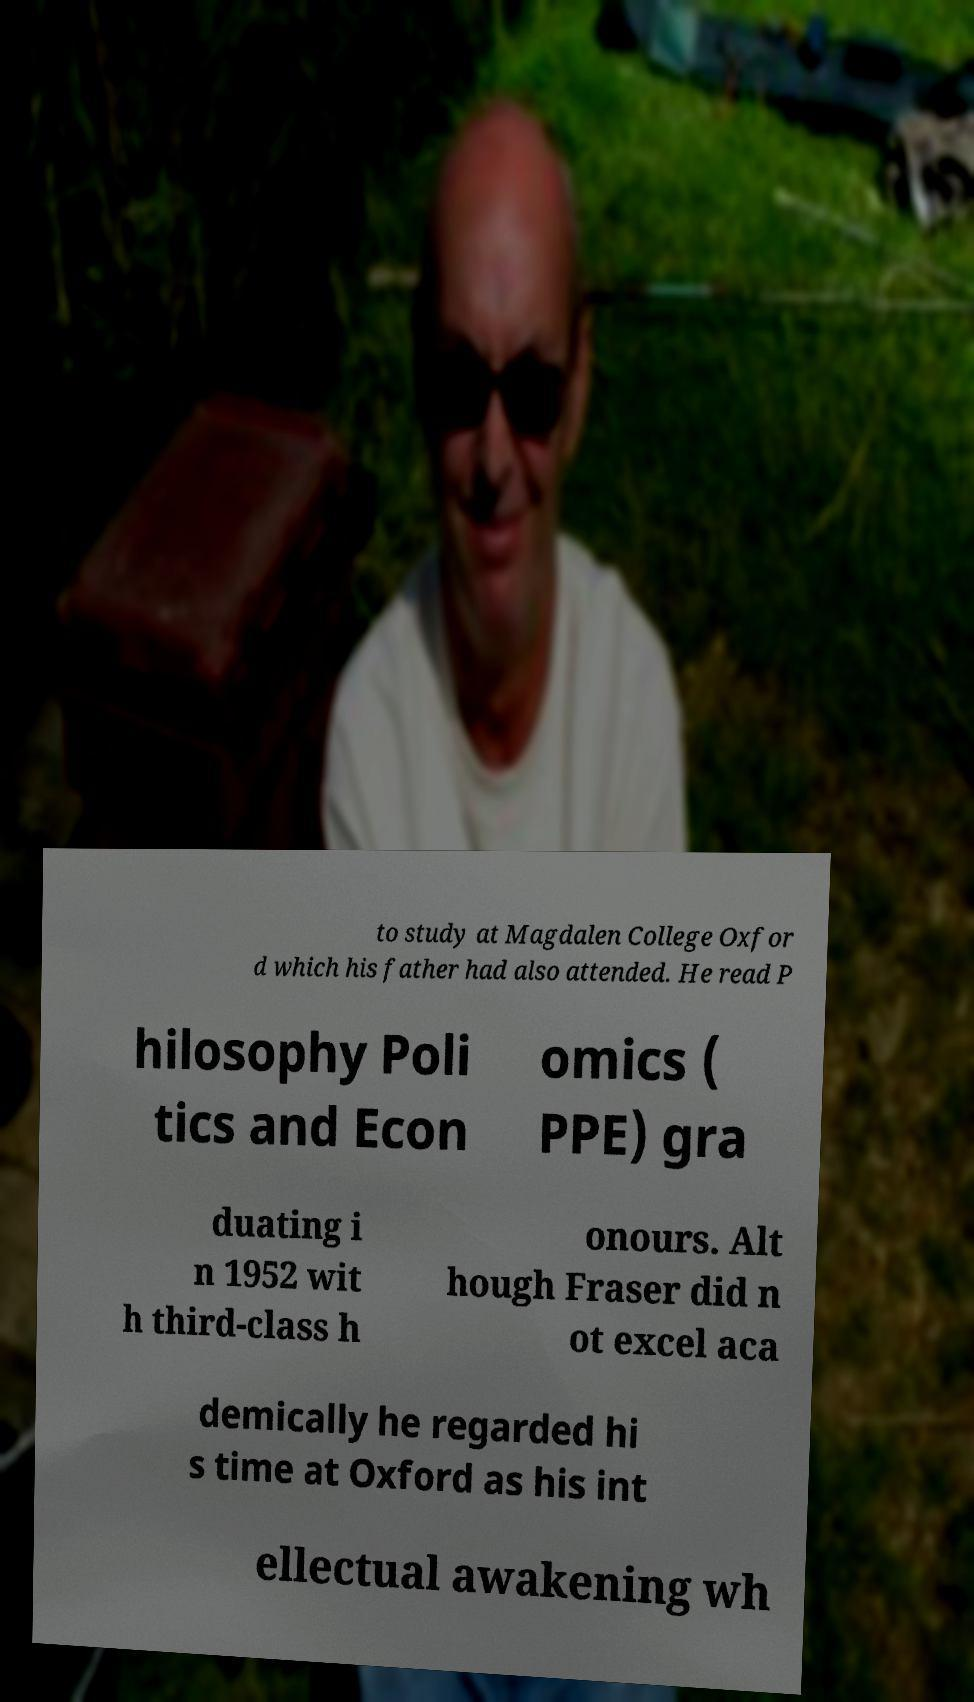Could you extract and type out the text from this image? to study at Magdalen College Oxfor d which his father had also attended. He read P hilosophy Poli tics and Econ omics ( PPE) gra duating i n 1952 wit h third-class h onours. Alt hough Fraser did n ot excel aca demically he regarded hi s time at Oxford as his int ellectual awakening wh 